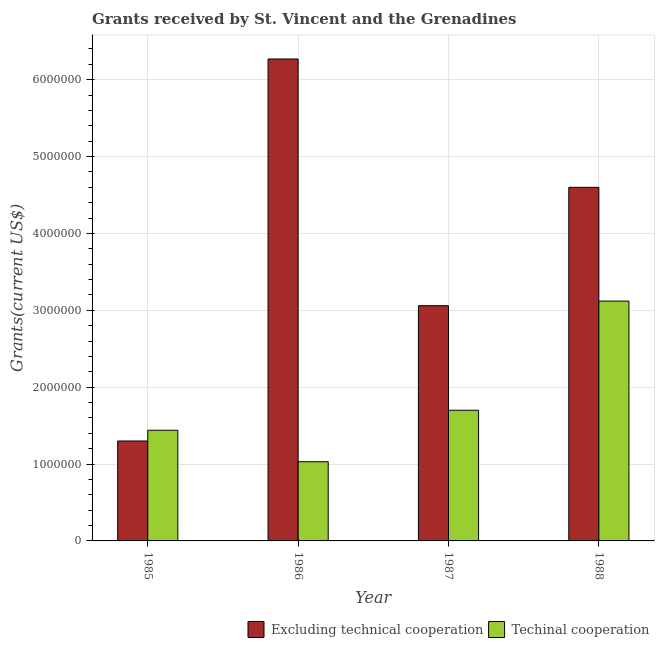Are the number of bars on each tick of the X-axis equal?
Make the answer very short. Yes. How many bars are there on the 3rd tick from the left?
Give a very brief answer. 2. What is the label of the 4th group of bars from the left?
Provide a short and direct response. 1988. In how many cases, is the number of bars for a given year not equal to the number of legend labels?
Ensure brevity in your answer.  0. What is the amount of grants received(excluding technical cooperation) in 1987?
Offer a very short reply. 3.06e+06. Across all years, what is the maximum amount of grants received(excluding technical cooperation)?
Offer a very short reply. 6.27e+06. Across all years, what is the minimum amount of grants received(including technical cooperation)?
Your response must be concise. 1.03e+06. In which year was the amount of grants received(including technical cooperation) maximum?
Your answer should be compact. 1988. In which year was the amount of grants received(including technical cooperation) minimum?
Your response must be concise. 1986. What is the total amount of grants received(excluding technical cooperation) in the graph?
Give a very brief answer. 1.52e+07. What is the difference between the amount of grants received(excluding technical cooperation) in 1985 and that in 1988?
Your answer should be compact. -3.30e+06. What is the difference between the amount of grants received(excluding technical cooperation) in 1988 and the amount of grants received(including technical cooperation) in 1985?
Your answer should be compact. 3.30e+06. What is the average amount of grants received(excluding technical cooperation) per year?
Provide a succinct answer. 3.81e+06. In the year 1986, what is the difference between the amount of grants received(excluding technical cooperation) and amount of grants received(including technical cooperation)?
Your answer should be very brief. 0. In how many years, is the amount of grants received(including technical cooperation) greater than 2400000 US$?
Offer a terse response. 1. What is the ratio of the amount of grants received(including technical cooperation) in 1987 to that in 1988?
Keep it short and to the point. 0.54. Is the amount of grants received(excluding technical cooperation) in 1987 less than that in 1988?
Ensure brevity in your answer.  Yes. What is the difference between the highest and the second highest amount of grants received(excluding technical cooperation)?
Offer a very short reply. 1.67e+06. What is the difference between the highest and the lowest amount of grants received(excluding technical cooperation)?
Your answer should be very brief. 4.97e+06. Is the sum of the amount of grants received(including technical cooperation) in 1987 and 1988 greater than the maximum amount of grants received(excluding technical cooperation) across all years?
Give a very brief answer. Yes. What does the 2nd bar from the left in 1987 represents?
Keep it short and to the point. Techinal cooperation. What does the 1st bar from the right in 1985 represents?
Offer a terse response. Techinal cooperation. Are all the bars in the graph horizontal?
Your response must be concise. No. What is the difference between two consecutive major ticks on the Y-axis?
Provide a short and direct response. 1.00e+06. Are the values on the major ticks of Y-axis written in scientific E-notation?
Make the answer very short. No. Does the graph contain grids?
Provide a short and direct response. Yes. Where does the legend appear in the graph?
Offer a terse response. Bottom right. How are the legend labels stacked?
Your answer should be very brief. Horizontal. What is the title of the graph?
Provide a short and direct response. Grants received by St. Vincent and the Grenadines. Does "Excluding technical cooperation" appear as one of the legend labels in the graph?
Your response must be concise. Yes. What is the label or title of the Y-axis?
Offer a terse response. Grants(current US$). What is the Grants(current US$) of Excluding technical cooperation in 1985?
Offer a very short reply. 1.30e+06. What is the Grants(current US$) of Techinal cooperation in 1985?
Provide a succinct answer. 1.44e+06. What is the Grants(current US$) of Excluding technical cooperation in 1986?
Offer a terse response. 6.27e+06. What is the Grants(current US$) in Techinal cooperation in 1986?
Keep it short and to the point. 1.03e+06. What is the Grants(current US$) in Excluding technical cooperation in 1987?
Offer a very short reply. 3.06e+06. What is the Grants(current US$) of Techinal cooperation in 1987?
Keep it short and to the point. 1.70e+06. What is the Grants(current US$) of Excluding technical cooperation in 1988?
Ensure brevity in your answer.  4.60e+06. What is the Grants(current US$) in Techinal cooperation in 1988?
Ensure brevity in your answer.  3.12e+06. Across all years, what is the maximum Grants(current US$) of Excluding technical cooperation?
Your answer should be compact. 6.27e+06. Across all years, what is the maximum Grants(current US$) of Techinal cooperation?
Your answer should be compact. 3.12e+06. Across all years, what is the minimum Grants(current US$) in Excluding technical cooperation?
Ensure brevity in your answer.  1.30e+06. Across all years, what is the minimum Grants(current US$) of Techinal cooperation?
Give a very brief answer. 1.03e+06. What is the total Grants(current US$) in Excluding technical cooperation in the graph?
Provide a succinct answer. 1.52e+07. What is the total Grants(current US$) of Techinal cooperation in the graph?
Give a very brief answer. 7.29e+06. What is the difference between the Grants(current US$) of Excluding technical cooperation in 1985 and that in 1986?
Provide a succinct answer. -4.97e+06. What is the difference between the Grants(current US$) of Excluding technical cooperation in 1985 and that in 1987?
Your answer should be very brief. -1.76e+06. What is the difference between the Grants(current US$) of Techinal cooperation in 1985 and that in 1987?
Provide a short and direct response. -2.60e+05. What is the difference between the Grants(current US$) in Excluding technical cooperation in 1985 and that in 1988?
Your response must be concise. -3.30e+06. What is the difference between the Grants(current US$) in Techinal cooperation in 1985 and that in 1988?
Offer a terse response. -1.68e+06. What is the difference between the Grants(current US$) of Excluding technical cooperation in 1986 and that in 1987?
Provide a succinct answer. 3.21e+06. What is the difference between the Grants(current US$) of Techinal cooperation in 1986 and that in 1987?
Make the answer very short. -6.70e+05. What is the difference between the Grants(current US$) in Excluding technical cooperation in 1986 and that in 1988?
Make the answer very short. 1.67e+06. What is the difference between the Grants(current US$) in Techinal cooperation in 1986 and that in 1988?
Your answer should be compact. -2.09e+06. What is the difference between the Grants(current US$) in Excluding technical cooperation in 1987 and that in 1988?
Ensure brevity in your answer.  -1.54e+06. What is the difference between the Grants(current US$) of Techinal cooperation in 1987 and that in 1988?
Provide a succinct answer. -1.42e+06. What is the difference between the Grants(current US$) in Excluding technical cooperation in 1985 and the Grants(current US$) in Techinal cooperation in 1986?
Ensure brevity in your answer.  2.70e+05. What is the difference between the Grants(current US$) in Excluding technical cooperation in 1985 and the Grants(current US$) in Techinal cooperation in 1987?
Give a very brief answer. -4.00e+05. What is the difference between the Grants(current US$) in Excluding technical cooperation in 1985 and the Grants(current US$) in Techinal cooperation in 1988?
Make the answer very short. -1.82e+06. What is the difference between the Grants(current US$) of Excluding technical cooperation in 1986 and the Grants(current US$) of Techinal cooperation in 1987?
Your answer should be very brief. 4.57e+06. What is the difference between the Grants(current US$) in Excluding technical cooperation in 1986 and the Grants(current US$) in Techinal cooperation in 1988?
Your answer should be compact. 3.15e+06. What is the average Grants(current US$) of Excluding technical cooperation per year?
Keep it short and to the point. 3.81e+06. What is the average Grants(current US$) of Techinal cooperation per year?
Your answer should be very brief. 1.82e+06. In the year 1985, what is the difference between the Grants(current US$) of Excluding technical cooperation and Grants(current US$) of Techinal cooperation?
Keep it short and to the point. -1.40e+05. In the year 1986, what is the difference between the Grants(current US$) in Excluding technical cooperation and Grants(current US$) in Techinal cooperation?
Offer a very short reply. 5.24e+06. In the year 1987, what is the difference between the Grants(current US$) of Excluding technical cooperation and Grants(current US$) of Techinal cooperation?
Provide a succinct answer. 1.36e+06. In the year 1988, what is the difference between the Grants(current US$) in Excluding technical cooperation and Grants(current US$) in Techinal cooperation?
Your response must be concise. 1.48e+06. What is the ratio of the Grants(current US$) in Excluding technical cooperation in 1985 to that in 1986?
Your answer should be compact. 0.21. What is the ratio of the Grants(current US$) in Techinal cooperation in 1985 to that in 1986?
Offer a very short reply. 1.4. What is the ratio of the Grants(current US$) of Excluding technical cooperation in 1985 to that in 1987?
Offer a very short reply. 0.42. What is the ratio of the Grants(current US$) in Techinal cooperation in 1985 to that in 1987?
Make the answer very short. 0.85. What is the ratio of the Grants(current US$) in Excluding technical cooperation in 1985 to that in 1988?
Offer a very short reply. 0.28. What is the ratio of the Grants(current US$) in Techinal cooperation in 1985 to that in 1988?
Make the answer very short. 0.46. What is the ratio of the Grants(current US$) of Excluding technical cooperation in 1986 to that in 1987?
Give a very brief answer. 2.05. What is the ratio of the Grants(current US$) of Techinal cooperation in 1986 to that in 1987?
Provide a short and direct response. 0.61. What is the ratio of the Grants(current US$) in Excluding technical cooperation in 1986 to that in 1988?
Offer a very short reply. 1.36. What is the ratio of the Grants(current US$) in Techinal cooperation in 1986 to that in 1988?
Offer a very short reply. 0.33. What is the ratio of the Grants(current US$) of Excluding technical cooperation in 1987 to that in 1988?
Provide a succinct answer. 0.67. What is the ratio of the Grants(current US$) in Techinal cooperation in 1987 to that in 1988?
Offer a very short reply. 0.54. What is the difference between the highest and the second highest Grants(current US$) of Excluding technical cooperation?
Offer a terse response. 1.67e+06. What is the difference between the highest and the second highest Grants(current US$) of Techinal cooperation?
Your answer should be compact. 1.42e+06. What is the difference between the highest and the lowest Grants(current US$) in Excluding technical cooperation?
Provide a short and direct response. 4.97e+06. What is the difference between the highest and the lowest Grants(current US$) of Techinal cooperation?
Ensure brevity in your answer.  2.09e+06. 